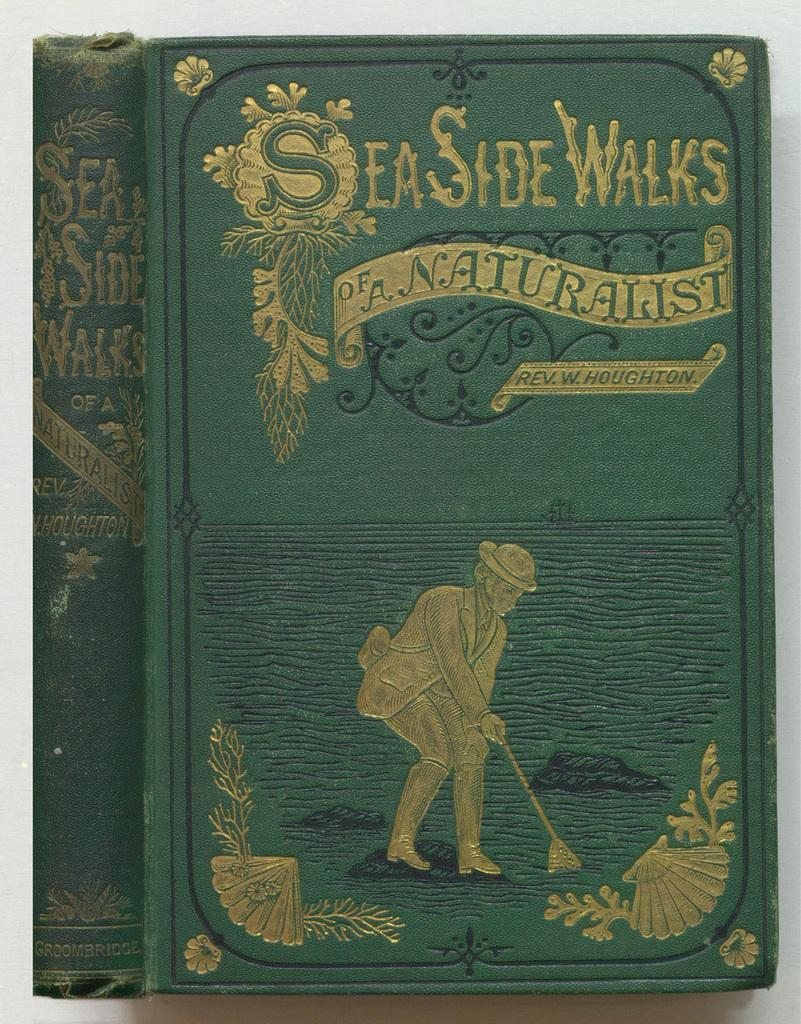<image>
Give a short and clear explanation of the subsequent image. Sea Side Walks the novel with a man bending with a broom on the cover. 